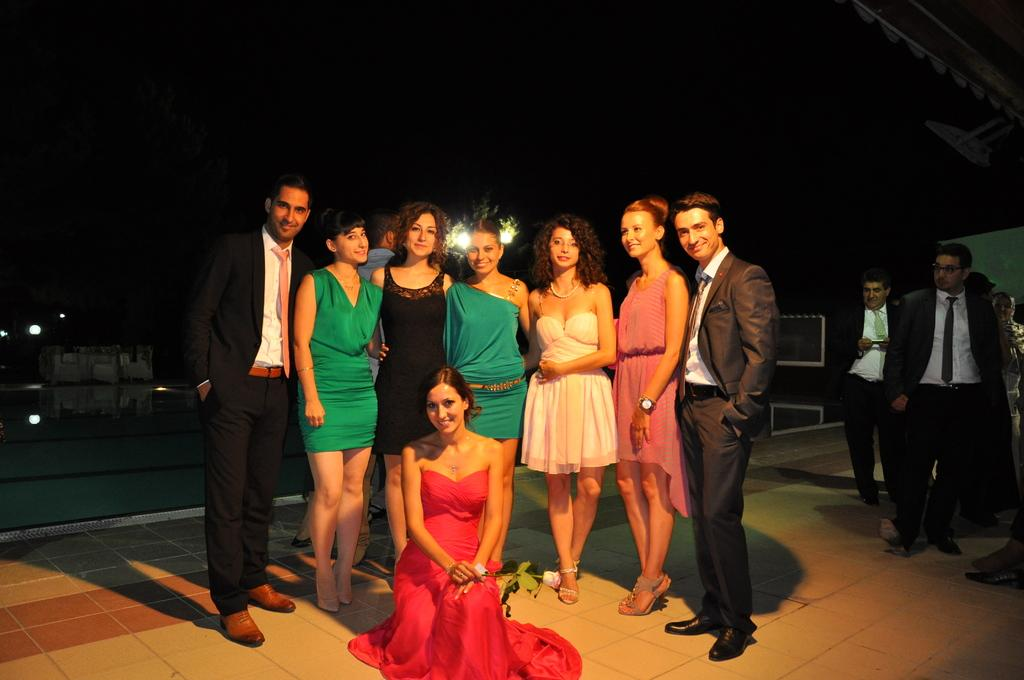What can be seen in the image? There are people standing in the image. What is at the bottom of the image? There is a floor at the bottom of the image. What is visible in the background of the image? There is sky and trees visible in the background of the image. What type of soda is being served in the image? There is no soda present in the image. How does the toothpaste relate to the people standing in the image? There is no toothpaste present in the image, so it does not relate to the people standing. 